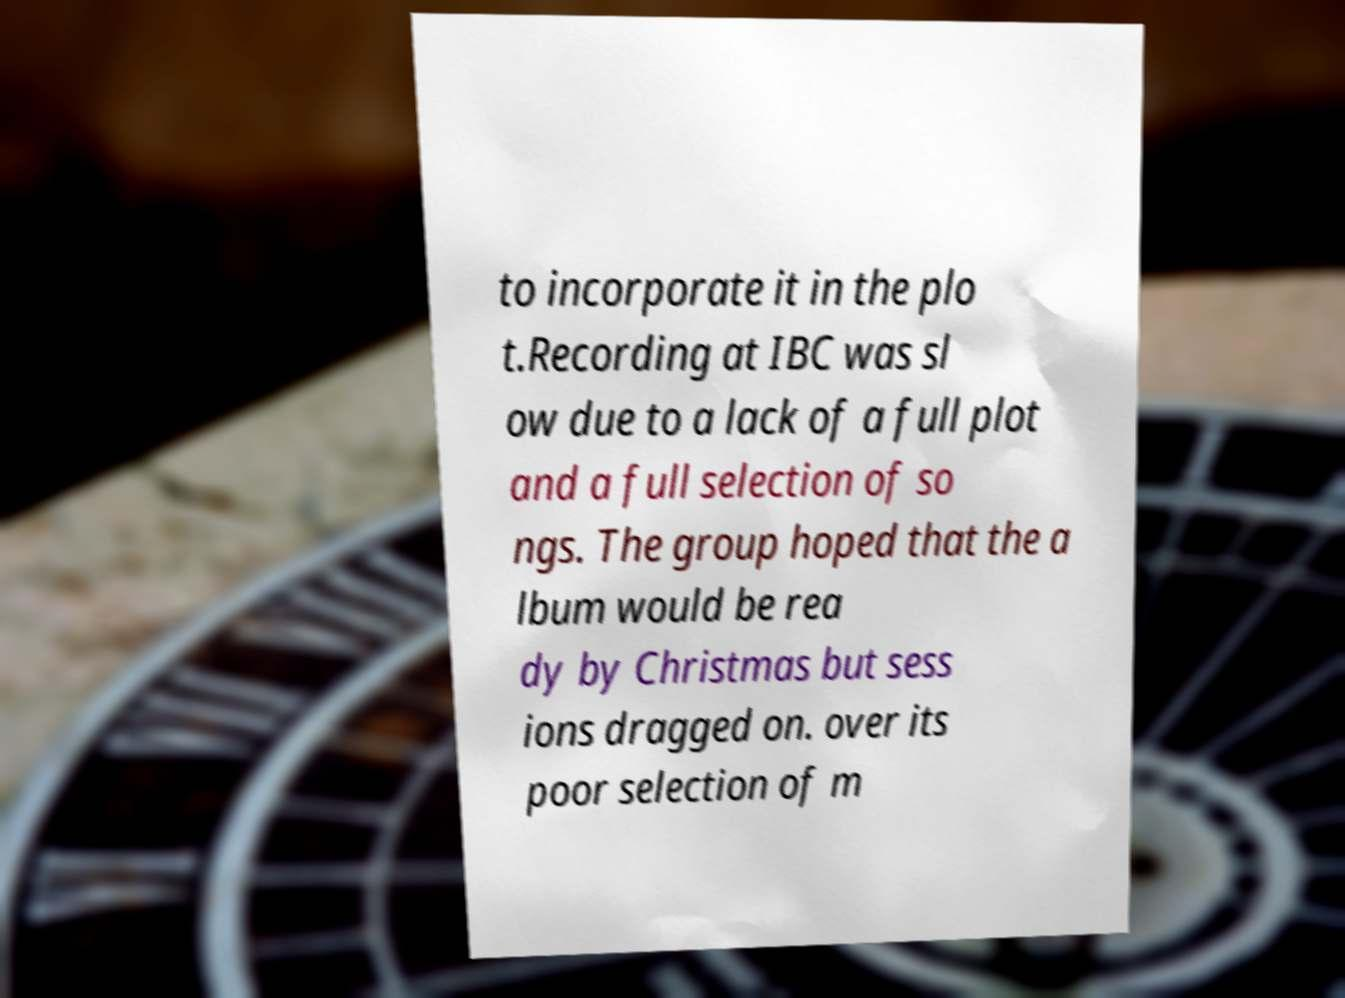Could you assist in decoding the text presented in this image and type it out clearly? to incorporate it in the plo t.Recording at IBC was sl ow due to a lack of a full plot and a full selection of so ngs. The group hoped that the a lbum would be rea dy by Christmas but sess ions dragged on. over its poor selection of m 